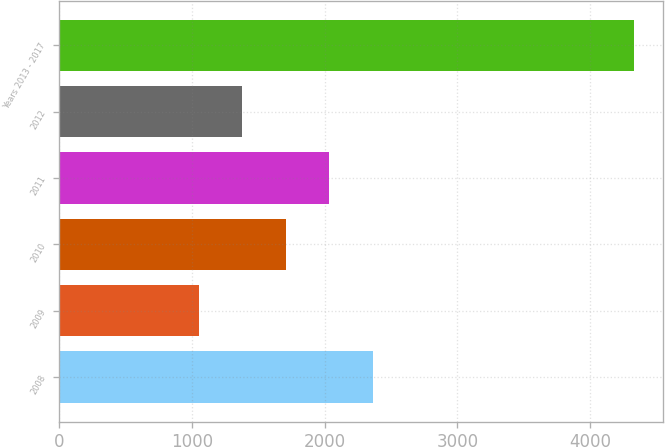<chart> <loc_0><loc_0><loc_500><loc_500><bar_chart><fcel>2008<fcel>2009<fcel>2010<fcel>2011<fcel>2012<fcel>Years 2013 - 2017<nl><fcel>2364.2<fcel>1053<fcel>1708.6<fcel>2036.4<fcel>1380.8<fcel>4331<nl></chart> 